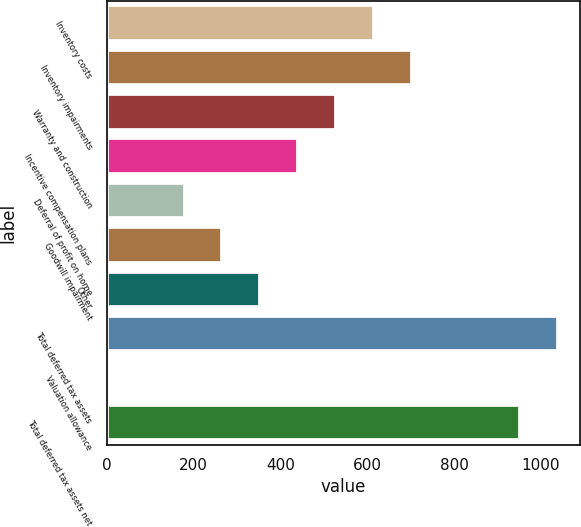Convert chart. <chart><loc_0><loc_0><loc_500><loc_500><bar_chart><fcel>Inventory costs<fcel>Inventory impairments<fcel>Warranty and construction<fcel>Incentive compensation plans<fcel>Deferral of profit on home<fcel>Goodwill impairment<fcel>Other<fcel>Total deferred tax assets<fcel>Valuation allowance<fcel>Total deferred tax assets net<nl><fcel>615.94<fcel>703.26<fcel>528.62<fcel>441.3<fcel>179.34<fcel>266.66<fcel>353.98<fcel>1038.44<fcel>4.7<fcel>951.12<nl></chart> 